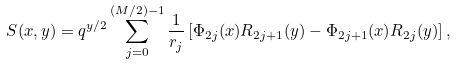Convert formula to latex. <formula><loc_0><loc_0><loc_500><loc_500>S ( x , y ) = q ^ { y / 2 } \sum _ { j = 0 } ^ { ( M / 2 ) - 1 } \frac { 1 } { r _ { j } } \left [ \Phi _ { 2 j } ( x ) R _ { 2 j + 1 } ( y ) - \Phi _ { 2 j + 1 } ( x ) R _ { 2 j } ( y ) \right ] ,</formula> 